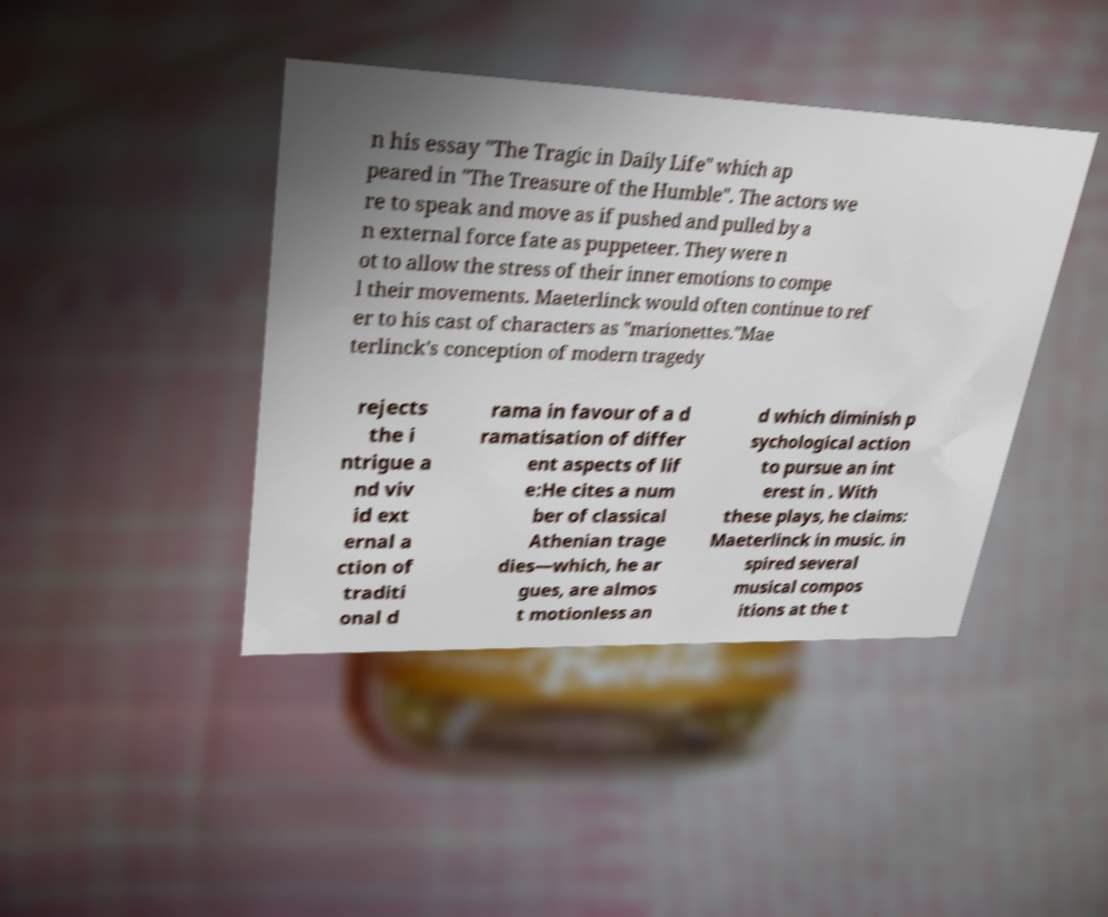I need the written content from this picture converted into text. Can you do that? n his essay "The Tragic in Daily Life" which ap peared in "The Treasure of the Humble". The actors we re to speak and move as if pushed and pulled by a n external force fate as puppeteer. They were n ot to allow the stress of their inner emotions to compe l their movements. Maeterlinck would often continue to ref er to his cast of characters as "marionettes."Mae terlinck's conception of modern tragedy rejects the i ntrigue a nd viv id ext ernal a ction of traditi onal d rama in favour of a d ramatisation of differ ent aspects of lif e:He cites a num ber of classical Athenian trage dies—which, he ar gues, are almos t motionless an d which diminish p sychological action to pursue an int erest in . With these plays, he claims: Maeterlinck in music. in spired several musical compos itions at the t 